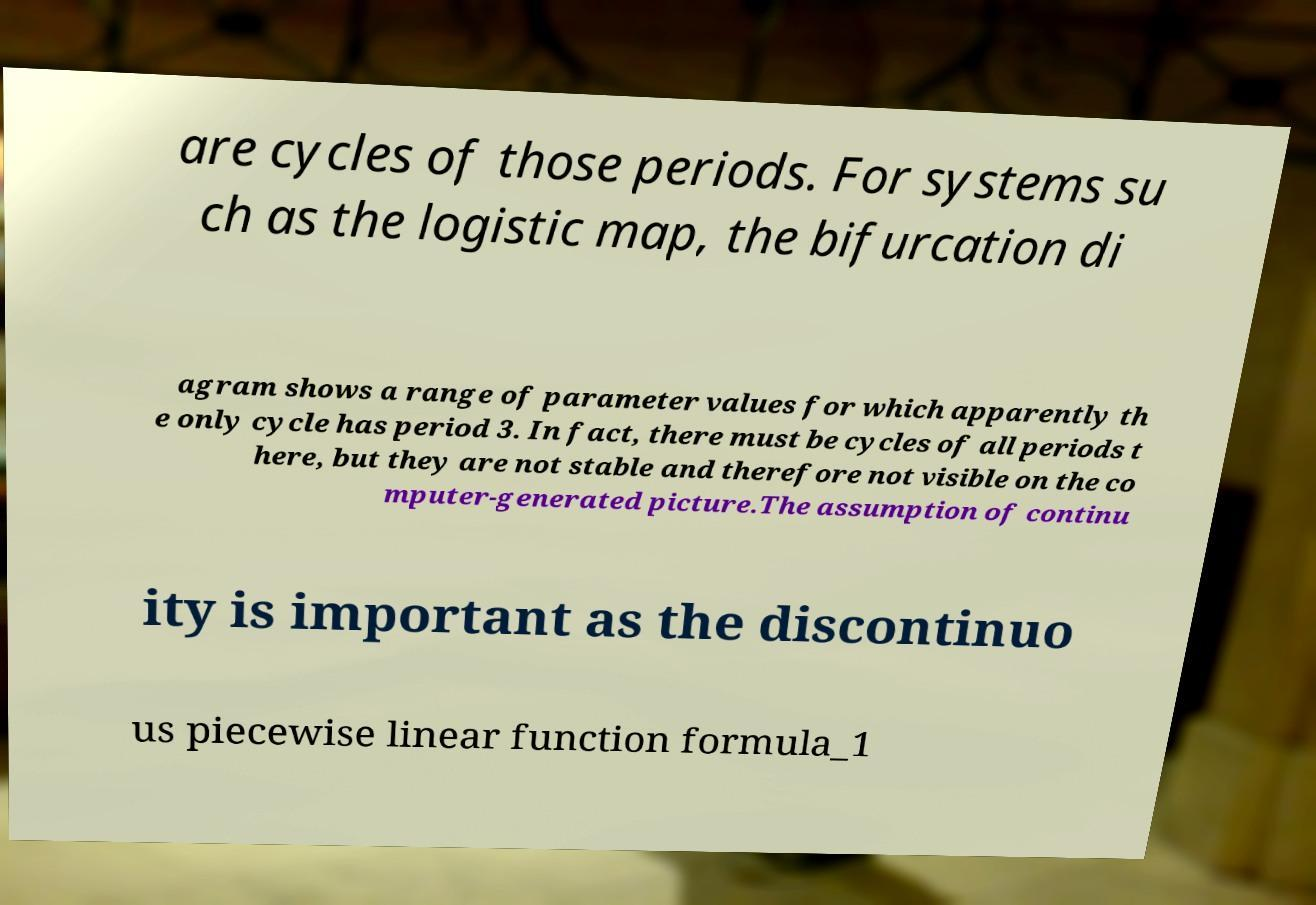Could you extract and type out the text from this image? are cycles of those periods. For systems su ch as the logistic map, the bifurcation di agram shows a range of parameter values for which apparently th e only cycle has period 3. In fact, there must be cycles of all periods t here, but they are not stable and therefore not visible on the co mputer-generated picture.The assumption of continu ity is important as the discontinuo us piecewise linear function formula_1 